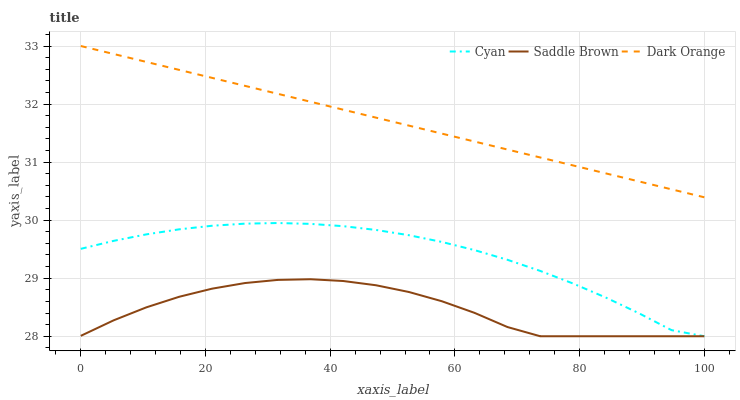Does Dark Orange have the minimum area under the curve?
Answer yes or no. No. Does Saddle Brown have the maximum area under the curve?
Answer yes or no. No. Is Saddle Brown the smoothest?
Answer yes or no. No. Is Dark Orange the roughest?
Answer yes or no. No. Does Dark Orange have the lowest value?
Answer yes or no. No. Does Saddle Brown have the highest value?
Answer yes or no. No. Is Saddle Brown less than Dark Orange?
Answer yes or no. Yes. Is Dark Orange greater than Saddle Brown?
Answer yes or no. Yes. Does Saddle Brown intersect Dark Orange?
Answer yes or no. No. 